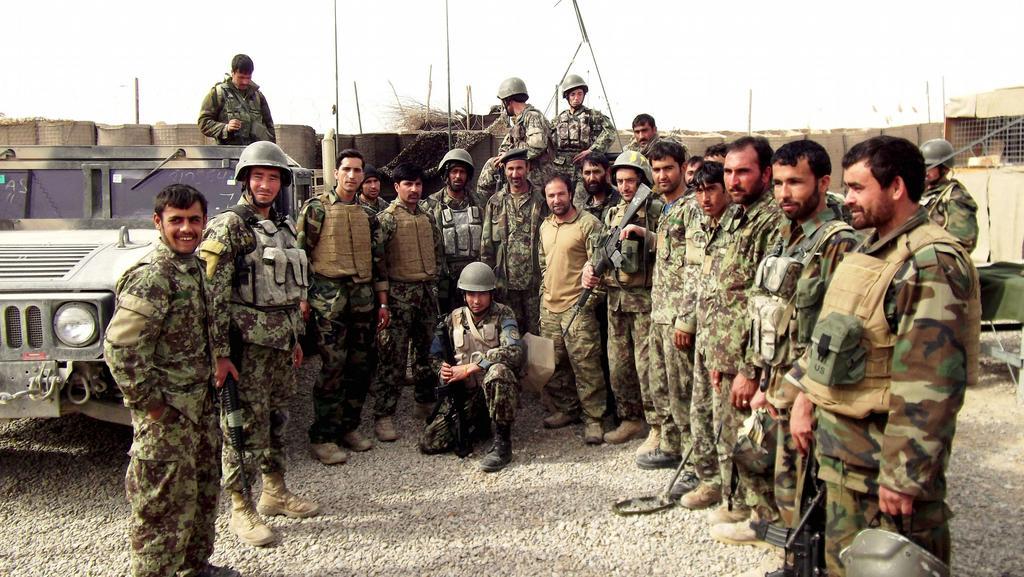Please provide a concise description of this image. In this picture I can see there are a group of army people standing wearing army uniforms and they are wearing bags and holding guns,weapons and onj to left I can see a jeep, I can see a person standing on the jeep. In the backdrop there is a wall. 